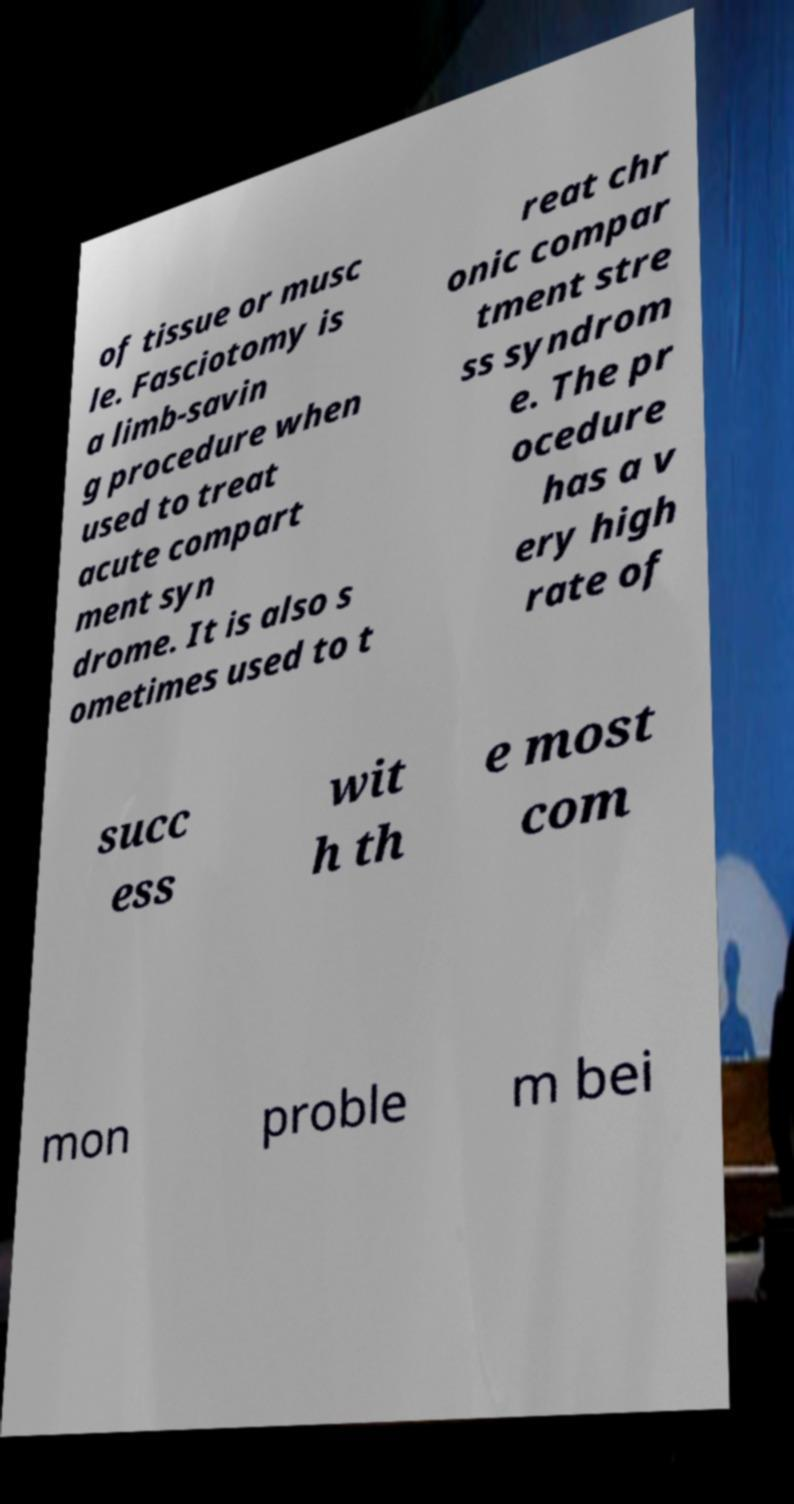Please read and relay the text visible in this image. What does it say? of tissue or musc le. Fasciotomy is a limb-savin g procedure when used to treat acute compart ment syn drome. It is also s ometimes used to t reat chr onic compar tment stre ss syndrom e. The pr ocedure has a v ery high rate of succ ess wit h th e most com mon proble m bei 